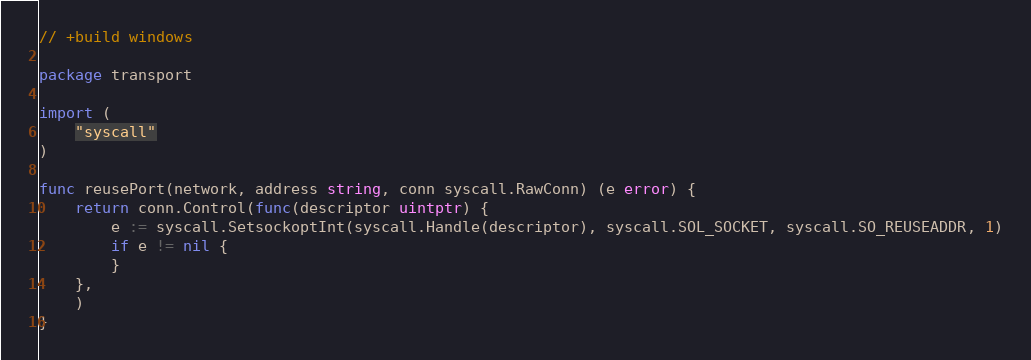Convert code to text. <code><loc_0><loc_0><loc_500><loc_500><_Go_>// +build windows

package transport

import (
	"syscall"
)

func reusePort(network, address string, conn syscall.RawConn) (e error) {
	return conn.Control(func(descriptor uintptr) {
		e := syscall.SetsockoptInt(syscall.Handle(descriptor), syscall.SOL_SOCKET, syscall.SO_REUSEADDR, 1)
		if e != nil {
		}
	},
	)
}
</code> 